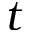Convert formula to latex. <formula><loc_0><loc_0><loc_500><loc_500>t</formula> 